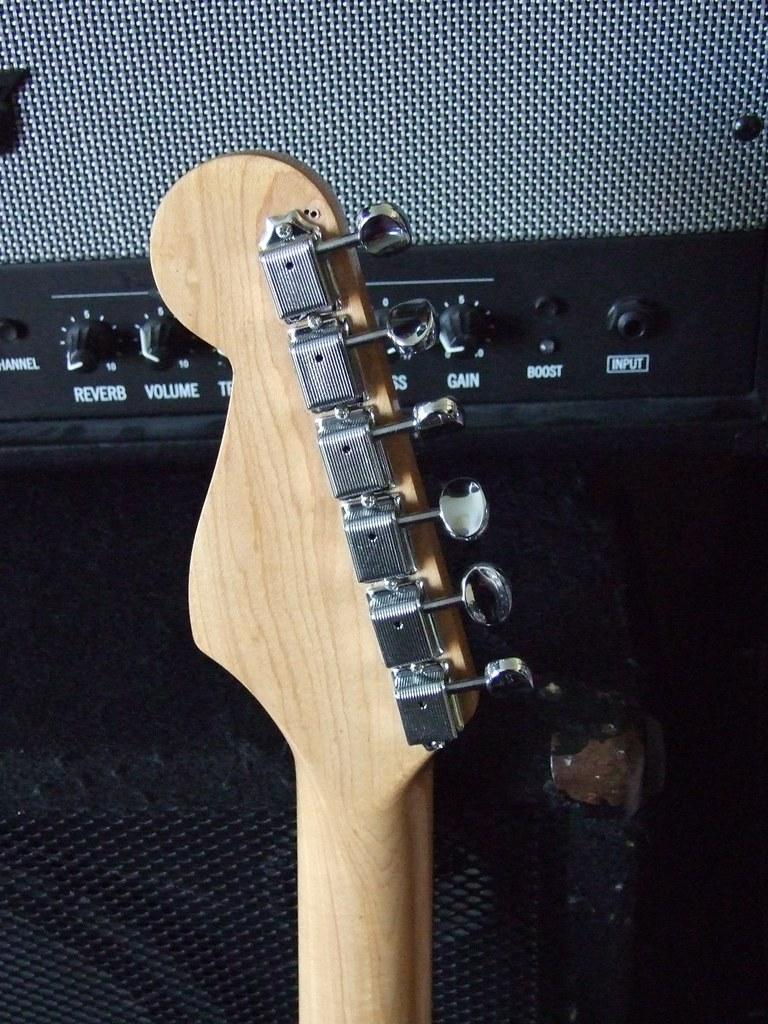What object is the main focus of the image? The main focus of the image is a guitar handle. What can be seen behind the guitar handle? There is a speaker visible behind the guitar handle. How many hands are holding the guitar in the image? There are no hands visible in the image, as it only shows a guitar handle and a speaker. Is there a pig present at the feast in the image? There is no feast or pig present in the image; it only features a guitar handle and a speaker. 